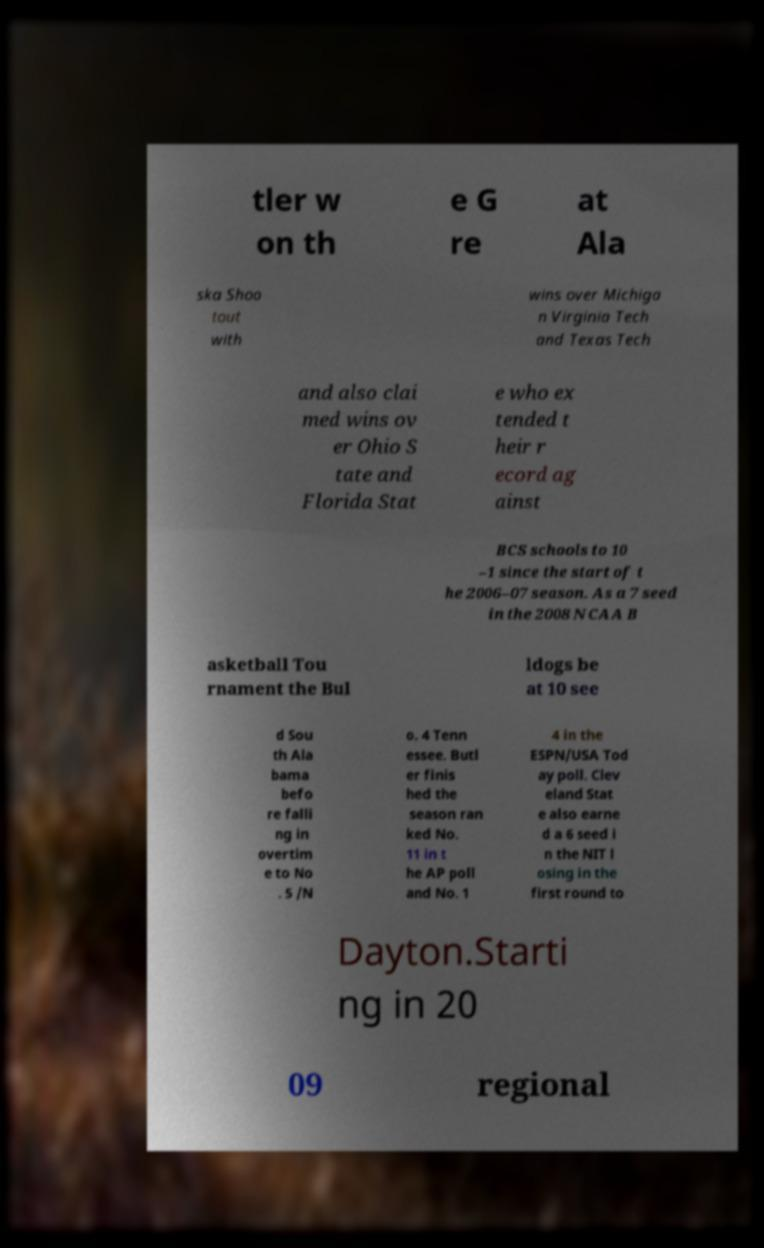Could you extract and type out the text from this image? tler w on th e G re at Ala ska Shoo tout with wins over Michiga n Virginia Tech and Texas Tech and also clai med wins ov er Ohio S tate and Florida Stat e who ex tended t heir r ecord ag ainst BCS schools to 10 –1 since the start of t he 2006–07 season. As a 7 seed in the 2008 NCAA B asketball Tou rnament the Bul ldogs be at 10 see d Sou th Ala bama befo re falli ng in overtim e to No . 5 /N o. 4 Tenn essee. Butl er finis hed the season ran ked No. 11 in t he AP poll and No. 1 4 in the ESPN/USA Tod ay poll. Clev eland Stat e also earne d a 6 seed i n the NIT l osing in the first round to Dayton.Starti ng in 20 09 regional 